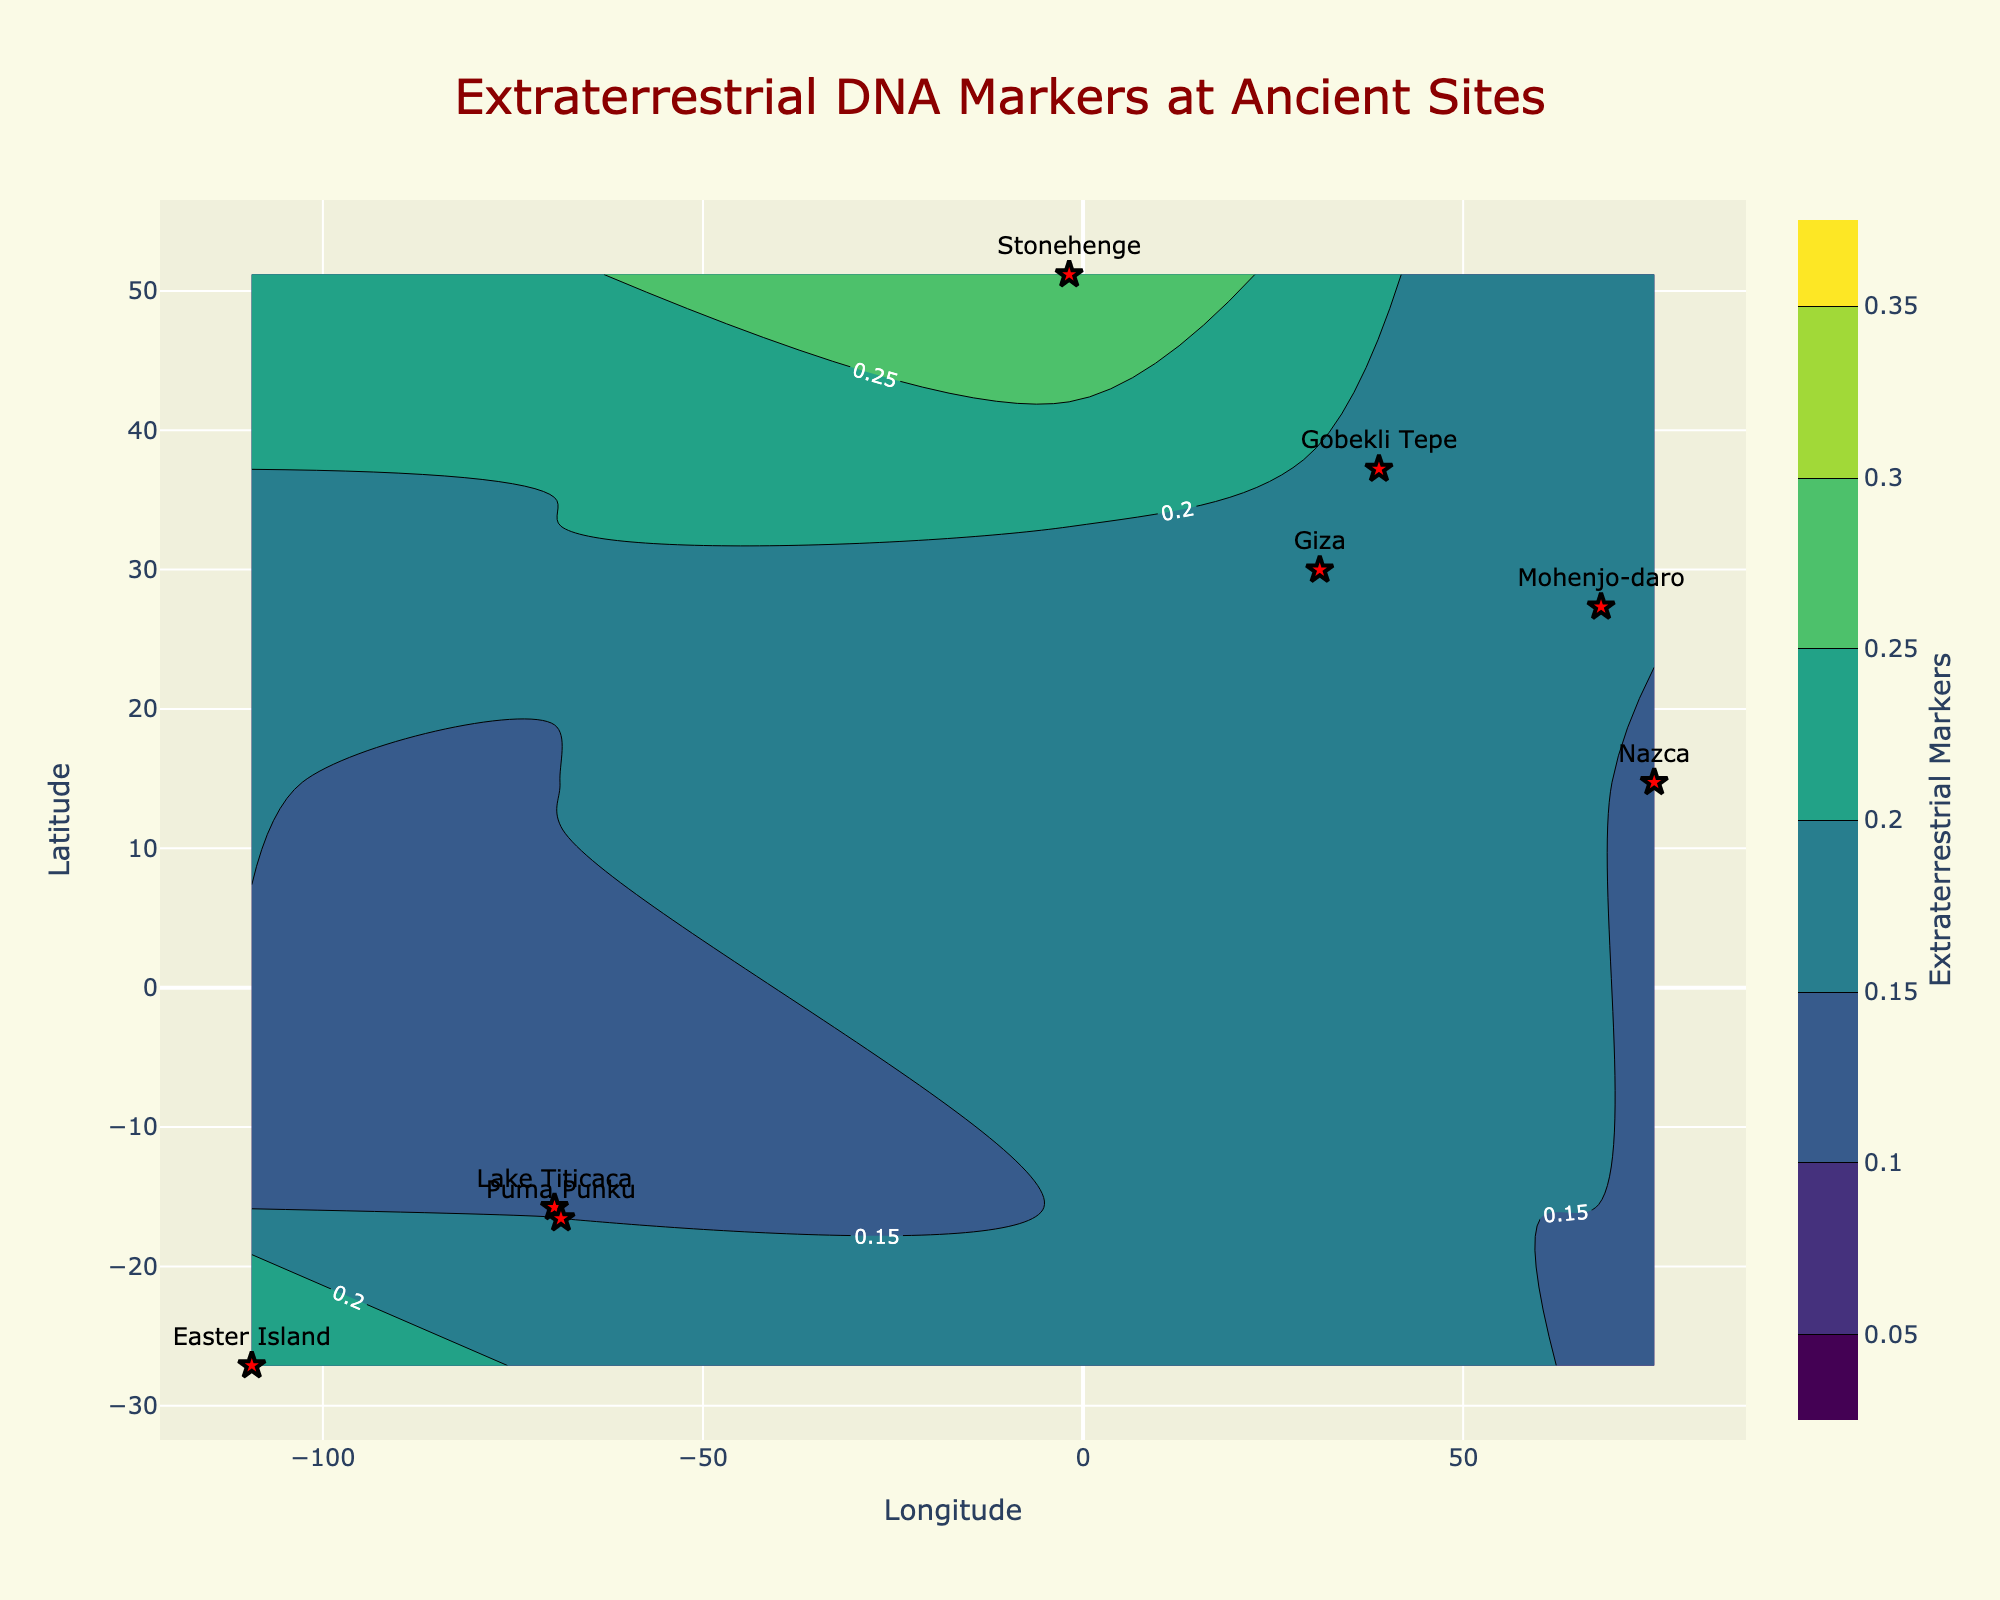What is the title of the plot? The title of the plot is usually located at the top and provides a summary of the figure. In this case, the figure title is “Extraterrestrial DNA Markers at Ancient Sites”.
Answer: Extraterrestrial DNA Markers at Ancient Sites How many ancient sites are displayed on the plot? By counting the red star markers on the plot and reading the labels, we can identify that there are 8 distinct ancient sites shown: Giza, Nazca, Stonehenge, Mohenjo-daro, Lake Titicaca, Gobekli Tepe, Puma Punku, and Easter Island.
Answer: 8 Which ancient site has the highest level of Extraterrestrial Markers? By checking the values at each labeled location, we can see that Stonehenge has the highest level of Extraterrestrial Markers with a value of 0.30.
Answer: Stonehenge What is the color scale used for the contour plot? The color scale used for the contour plot is labeled 'Viridis'. This can be identified by the blend of colors ranging from dark purple to bright yellow-green.
Answer: Viridis What is the range of the color bar for Extraterrestrial Markers? The color bar indicates the range of Extraterrestrial Markers values depicted by the contour plot, which starts from 0.05 and goes to 0.35.
Answer: 0.05 to 0.35 Which site is located at the southernmost latitude? By observing the y-axis (latitude), the site located at the southernmost point is Easter Island with a latitude of -27.1127.
Answer: Easter Island Which site shows a concentration of 0.15 for Extraterrestrial Markers? Analyzing the contour lines and the corresponding labels, the locations with Extraterrestrial Marker concentration of 0.15 are Giza and Puma Punku.
Answer: Giza and Puma Punku What is the average value of Extraterrestrial Markers across all the sites? Summing up the Extraterrestrial Markers values (0.15 + 0.12 + 0.30 + 0.20 + 0.10 + 0.18 + 0.15 + 0.25) and dividing by the number of sites (8), the average can be calculated as (1.45/8 = 0.18125).
Answer: 0.18125 Which site has the smallest difference between Ancient Markers and Extraterrestrial Markers? Calculating the difference at each site: Giza (0.7), Nazca (0.76), Stonehenge (0.40), Mohenjo-daro (0.60), Lake Titicaca (0.80), Gobekli Tepe (0.64), Puma Punku (0.70), Easter Island (0.50). The smallest difference is at Stonehenge (difference = 0.40).
Answer: Stonehenge What regions are shown to have an Extraterrestrial Markers value of exactly 0.10? By checking the contour levels and labels, the region with an exact level of 0.10 is Lake Titicaca.
Answer: Lake Titicaca 